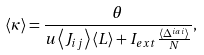Convert formula to latex. <formula><loc_0><loc_0><loc_500><loc_500>\langle \kappa \rangle = \frac { \theta } { u \left \langle J _ { i j } \right \rangle \left \langle L \right \rangle + I _ { e x t } \frac { \langle \Delta ^ { i a i } \rangle } { N } } ,</formula> 